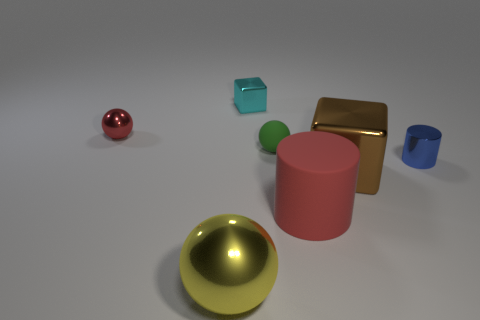Is the material of the small green ball the same as the yellow sphere?
Keep it short and to the point. No. The tiny object that is the same color as the big cylinder is what shape?
Ensure brevity in your answer.  Sphere. There is a tiny object that is left of the tiny metallic block; is it the same color as the large cylinder?
Your response must be concise. Yes. There is a sphere that is in front of the big red matte object; what number of red matte cylinders are on the right side of it?
Offer a very short reply. 1. The other metallic object that is the same size as the brown thing is what color?
Keep it short and to the point. Yellow. There is a red thing in front of the small red metal thing; what is its material?
Your response must be concise. Rubber. There is a sphere that is both left of the tiny green rubber sphere and behind the metallic cylinder; what material is it made of?
Your answer should be compact. Metal. Does the rubber object that is in front of the brown block have the same size as the tiny matte ball?
Provide a succinct answer. No. What is the shape of the tiny cyan object?
Offer a terse response. Cube. What number of other small red metallic objects have the same shape as the tiny red metal object?
Make the answer very short. 0. 